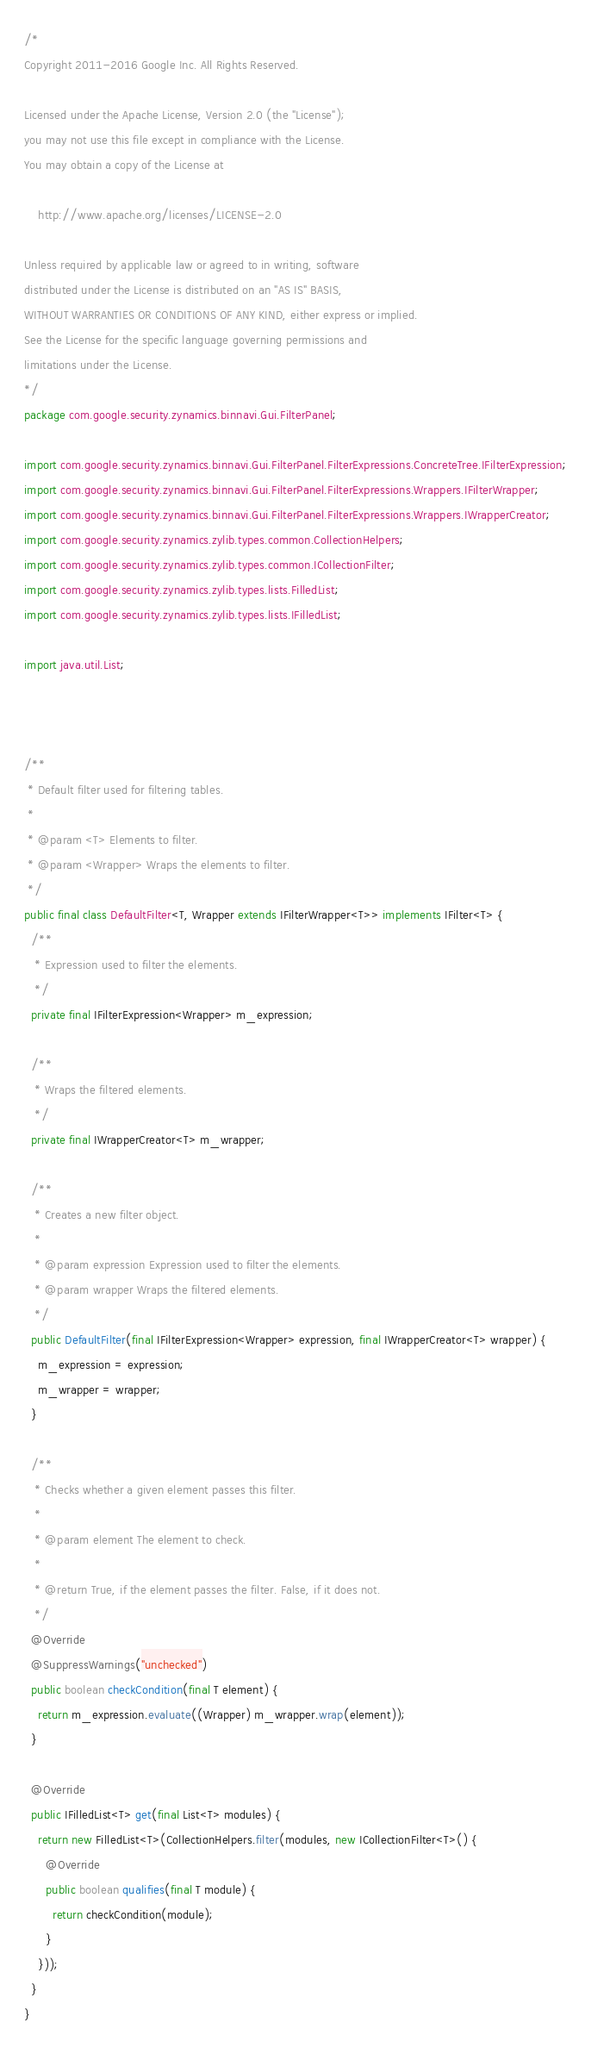Convert code to text. <code><loc_0><loc_0><loc_500><loc_500><_Java_>/*
Copyright 2011-2016 Google Inc. All Rights Reserved.

Licensed under the Apache License, Version 2.0 (the "License");
you may not use this file except in compliance with the License.
You may obtain a copy of the License at

    http://www.apache.org/licenses/LICENSE-2.0

Unless required by applicable law or agreed to in writing, software
distributed under the License is distributed on an "AS IS" BASIS,
WITHOUT WARRANTIES OR CONDITIONS OF ANY KIND, either express or implied.
See the License for the specific language governing permissions and
limitations under the License.
*/
package com.google.security.zynamics.binnavi.Gui.FilterPanel;

import com.google.security.zynamics.binnavi.Gui.FilterPanel.FilterExpressions.ConcreteTree.IFilterExpression;
import com.google.security.zynamics.binnavi.Gui.FilterPanel.FilterExpressions.Wrappers.IFilterWrapper;
import com.google.security.zynamics.binnavi.Gui.FilterPanel.FilterExpressions.Wrappers.IWrapperCreator;
import com.google.security.zynamics.zylib.types.common.CollectionHelpers;
import com.google.security.zynamics.zylib.types.common.ICollectionFilter;
import com.google.security.zynamics.zylib.types.lists.FilledList;
import com.google.security.zynamics.zylib.types.lists.IFilledList;

import java.util.List;



/**
 * Default filter used for filtering tables.
 * 
 * @param <T> Elements to filter.
 * @param <Wrapper> Wraps the elements to filter.
 */
public final class DefaultFilter<T, Wrapper extends IFilterWrapper<T>> implements IFilter<T> {
  /**
   * Expression used to filter the elements.
   */
  private final IFilterExpression<Wrapper> m_expression;

  /**
   * Wraps the filtered elements.
   */
  private final IWrapperCreator<T> m_wrapper;

  /**
   * Creates a new filter object.
   * 
   * @param expression Expression used to filter the elements.
   * @param wrapper Wraps the filtered elements.
   */
  public DefaultFilter(final IFilterExpression<Wrapper> expression, final IWrapperCreator<T> wrapper) {
    m_expression = expression;
    m_wrapper = wrapper;
  }

  /**
   * Checks whether a given element passes this filter.
   * 
   * @param element The element to check.
   * 
   * @return True, if the element passes the filter. False, if it does not.
   */
  @Override
  @SuppressWarnings("unchecked")
  public boolean checkCondition(final T element) {
    return m_expression.evaluate((Wrapper) m_wrapper.wrap(element));
  }

  @Override
  public IFilledList<T> get(final List<T> modules) {
    return new FilledList<T>(CollectionHelpers.filter(modules, new ICollectionFilter<T>() {
      @Override
      public boolean qualifies(final T module) {
        return checkCondition(module);
      }
    }));
  }
}
</code> 